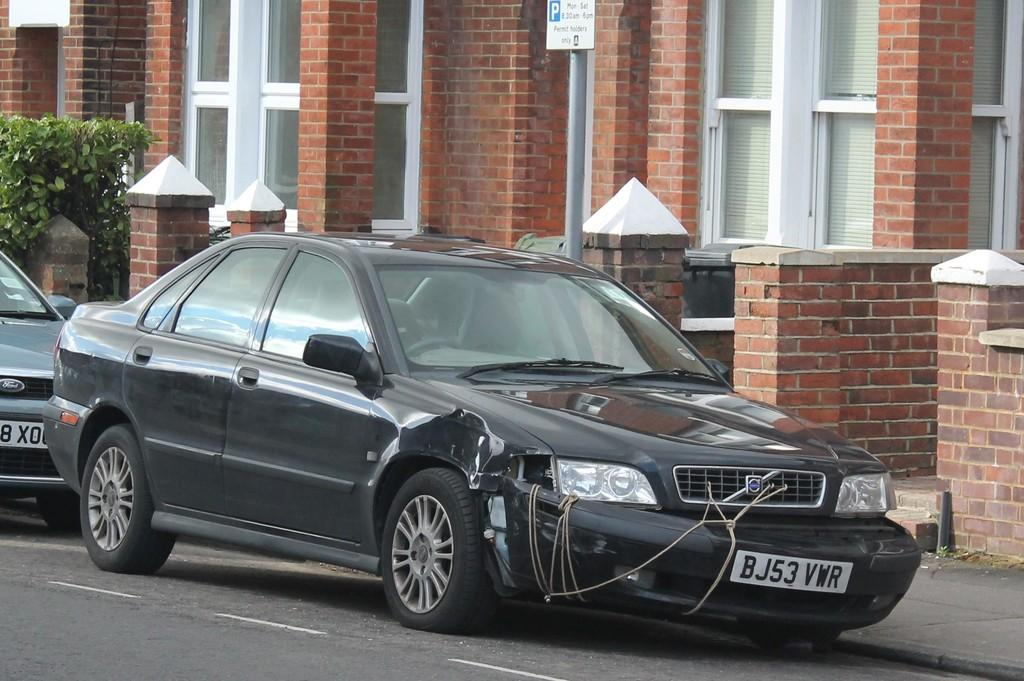<image>
Present a compact description of the photo's key features. A black car with the bumper secured with a rope with a license plate that reads BJ53VWR. 